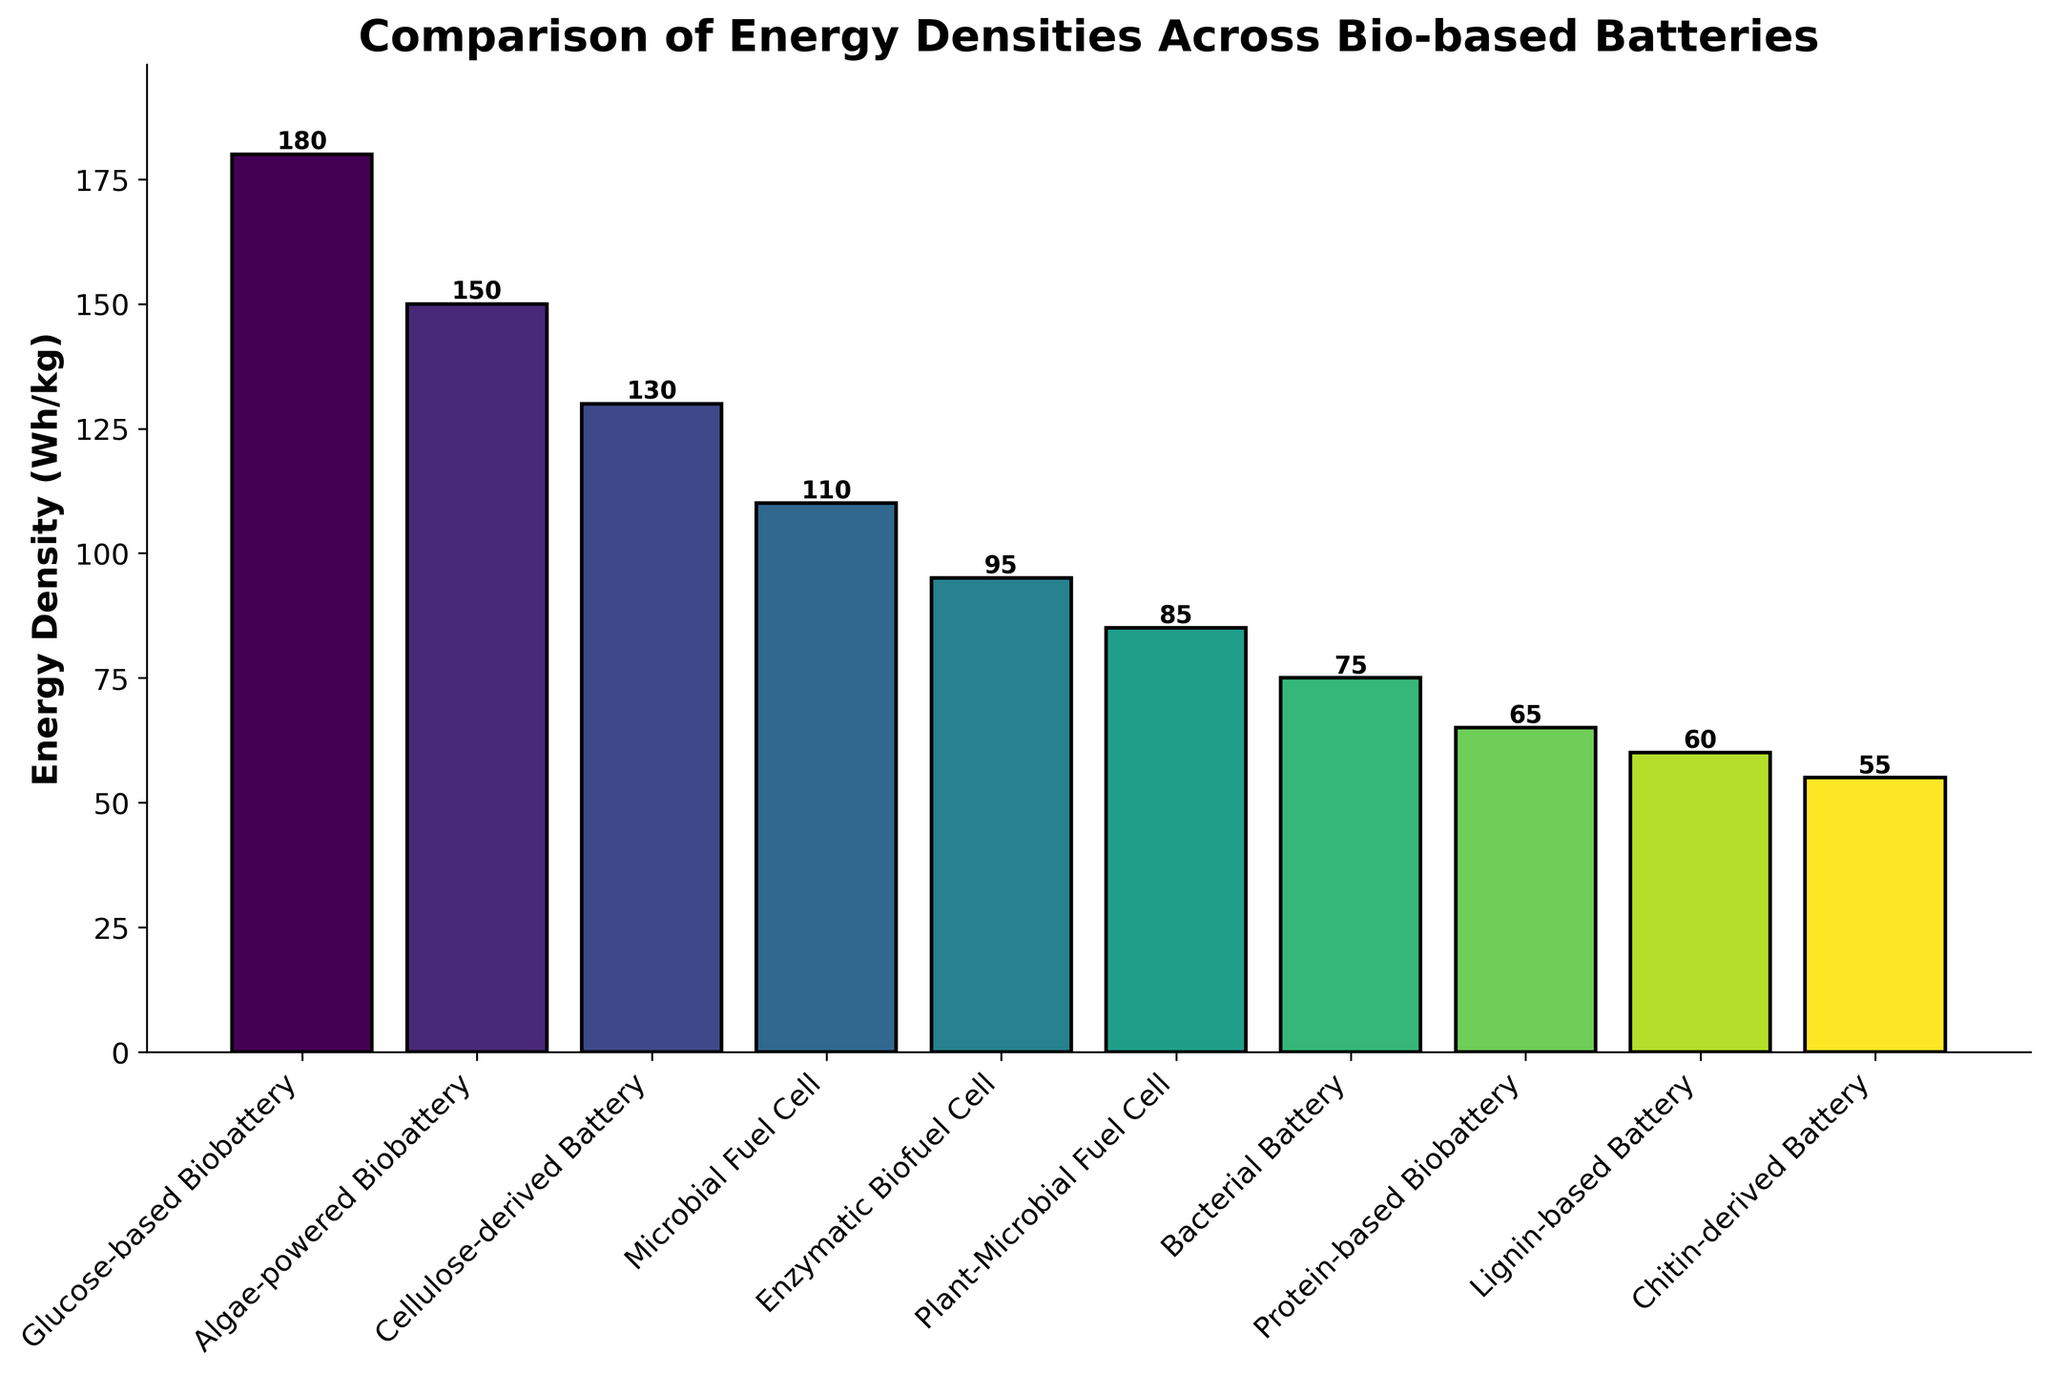Which battery type has the highest energy density? Look for the battery type with the tallest bar in the figure, which represents the highest energy density. The tallest bar corresponds to the Glucose-based Biobattery.
Answer: Glucose-based Biobattery Which battery type has the lowest energy density? Identify the battery type with the shortest bar in the figure. The shortest bar corresponds to the Chitin-derived Battery.
Answer: Chitin-derived Battery What is the difference in energy density between the Glucose-based Biobattery and the Bacterial Battery? Locate the heights of the bars representing the Glucose-based Biobattery and the Bacterial Battery. Subtract 75 Wh/kg (Bacterial Battery) from 180 Wh/kg (Glucose-based Biobattery).
Answer: 105 Wh/kg Which battery types have energy densities greater than 100 Wh/kg? Find all the bars that are taller than the 100 Wh/kg mark on the y-axis. These battery types are: Glucose-based Biobattery, Algae-powered Biobattery, Cellulose-derived Battery, and Microbial Fuel Cell.
Answer: Glucose-based Biobattery, Algae-powered Biobattery, Cellulose-derived Battery, Microbial Fuel Cell What is the average energy density of all the bio-based batteries depicted? Sum up all the energy densities and then divide by the number of battery types. The sum is 180 + 150 + 130 + 110 + 95 + 85 + 75 + 65 + 60 + 55 = 1005 Wh/kg. There are 10 battery types, so the average is 1005 / 10 = 100.5 Wh/kg.
Answer: 100.5 Wh/kg How does the energy density of the ProteBased BioBatte Compare the heights of the visual attributes of the Glucose-based Biobattery and the Enzymatic Biofuel Cell. Add their values (180 Wh/kg and 95.) and divide by two. The average energy density is 135g  h-dens 90
Answer: 22.5 Find the optimal energy lens Locate the energy density of the Microbial Fuel Cell and the difference between .
Answer: 25ucle What is the median value of the energy densiipferred to? Rorrect the data points and how their angles are ref the middle value of the list.
Answer: 105d What is the totot with the lowest energy battery? Locate the total energy density of that the Lignin-based
Answer: 17 